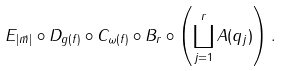Convert formula to latex. <formula><loc_0><loc_0><loc_500><loc_500>E _ { | \vec { m } | } \circ D _ { g ( f ) } \circ C _ { \omega ( f ) } \circ B _ { r } \circ \left ( \coprod _ { j = 1 } ^ { r } A ( q _ { j } ) \right ) .</formula> 